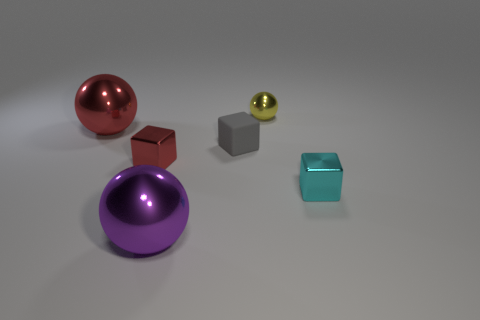Subtract 1 balls. How many balls are left? 2 Add 2 large red metal things. How many objects exist? 8 Add 2 spheres. How many spheres are left? 5 Add 3 small gray matte blocks. How many small gray matte blocks exist? 4 Subtract 0 purple cylinders. How many objects are left? 6 Subtract all brown cylinders. Subtract all tiny yellow objects. How many objects are left? 5 